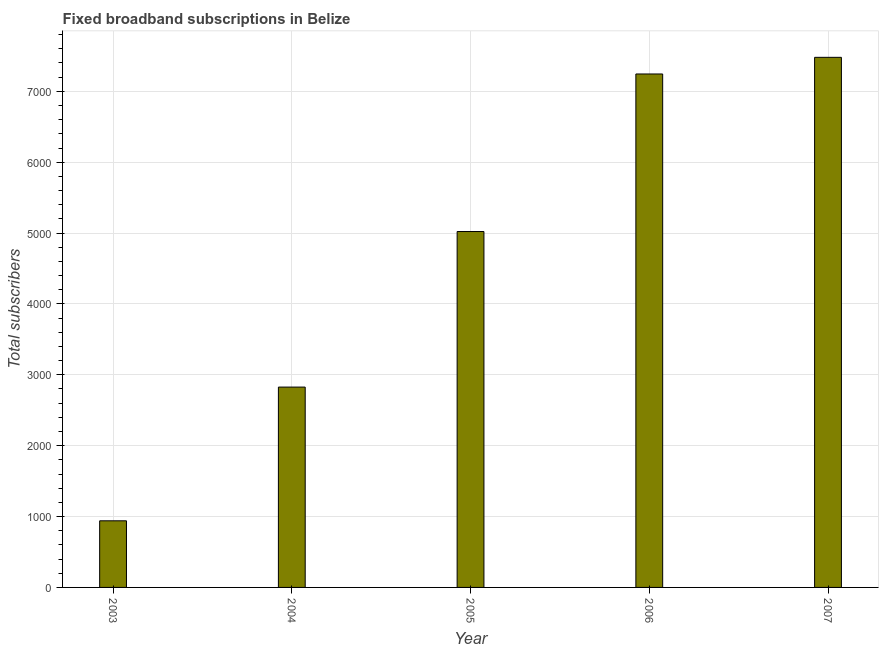Does the graph contain any zero values?
Your response must be concise. No. Does the graph contain grids?
Your response must be concise. Yes. What is the title of the graph?
Your response must be concise. Fixed broadband subscriptions in Belize. What is the label or title of the X-axis?
Provide a succinct answer. Year. What is the label or title of the Y-axis?
Keep it short and to the point. Total subscribers. What is the total number of fixed broadband subscriptions in 2005?
Your response must be concise. 5022. Across all years, what is the maximum total number of fixed broadband subscriptions?
Provide a succinct answer. 7480. Across all years, what is the minimum total number of fixed broadband subscriptions?
Give a very brief answer. 940. In which year was the total number of fixed broadband subscriptions maximum?
Give a very brief answer. 2007. In which year was the total number of fixed broadband subscriptions minimum?
Provide a short and direct response. 2003. What is the sum of the total number of fixed broadband subscriptions?
Offer a very short reply. 2.35e+04. What is the difference between the total number of fixed broadband subscriptions in 2005 and 2007?
Ensure brevity in your answer.  -2458. What is the average total number of fixed broadband subscriptions per year?
Your response must be concise. 4702. What is the median total number of fixed broadband subscriptions?
Offer a terse response. 5022. In how many years, is the total number of fixed broadband subscriptions greater than 1200 ?
Your response must be concise. 4. What is the ratio of the total number of fixed broadband subscriptions in 2006 to that in 2007?
Your response must be concise. 0.97. Is the total number of fixed broadband subscriptions in 2005 less than that in 2006?
Provide a succinct answer. Yes. What is the difference between the highest and the second highest total number of fixed broadband subscriptions?
Keep it short and to the point. 235. Is the sum of the total number of fixed broadband subscriptions in 2005 and 2007 greater than the maximum total number of fixed broadband subscriptions across all years?
Your response must be concise. Yes. What is the difference between the highest and the lowest total number of fixed broadband subscriptions?
Provide a succinct answer. 6540. How many bars are there?
Keep it short and to the point. 5. Are all the bars in the graph horizontal?
Offer a terse response. No. How many years are there in the graph?
Make the answer very short. 5. Are the values on the major ticks of Y-axis written in scientific E-notation?
Give a very brief answer. No. What is the Total subscribers in 2003?
Provide a succinct answer. 940. What is the Total subscribers in 2004?
Provide a short and direct response. 2827. What is the Total subscribers of 2005?
Provide a short and direct response. 5022. What is the Total subscribers of 2006?
Your answer should be compact. 7245. What is the Total subscribers in 2007?
Keep it short and to the point. 7480. What is the difference between the Total subscribers in 2003 and 2004?
Offer a very short reply. -1887. What is the difference between the Total subscribers in 2003 and 2005?
Ensure brevity in your answer.  -4082. What is the difference between the Total subscribers in 2003 and 2006?
Your answer should be very brief. -6305. What is the difference between the Total subscribers in 2003 and 2007?
Offer a terse response. -6540. What is the difference between the Total subscribers in 2004 and 2005?
Offer a very short reply. -2195. What is the difference between the Total subscribers in 2004 and 2006?
Offer a very short reply. -4418. What is the difference between the Total subscribers in 2004 and 2007?
Your response must be concise. -4653. What is the difference between the Total subscribers in 2005 and 2006?
Your answer should be compact. -2223. What is the difference between the Total subscribers in 2005 and 2007?
Your answer should be compact. -2458. What is the difference between the Total subscribers in 2006 and 2007?
Offer a terse response. -235. What is the ratio of the Total subscribers in 2003 to that in 2004?
Provide a short and direct response. 0.33. What is the ratio of the Total subscribers in 2003 to that in 2005?
Give a very brief answer. 0.19. What is the ratio of the Total subscribers in 2003 to that in 2006?
Your answer should be compact. 0.13. What is the ratio of the Total subscribers in 2003 to that in 2007?
Your answer should be compact. 0.13. What is the ratio of the Total subscribers in 2004 to that in 2005?
Offer a terse response. 0.56. What is the ratio of the Total subscribers in 2004 to that in 2006?
Ensure brevity in your answer.  0.39. What is the ratio of the Total subscribers in 2004 to that in 2007?
Provide a short and direct response. 0.38. What is the ratio of the Total subscribers in 2005 to that in 2006?
Offer a very short reply. 0.69. What is the ratio of the Total subscribers in 2005 to that in 2007?
Offer a very short reply. 0.67. What is the ratio of the Total subscribers in 2006 to that in 2007?
Give a very brief answer. 0.97. 